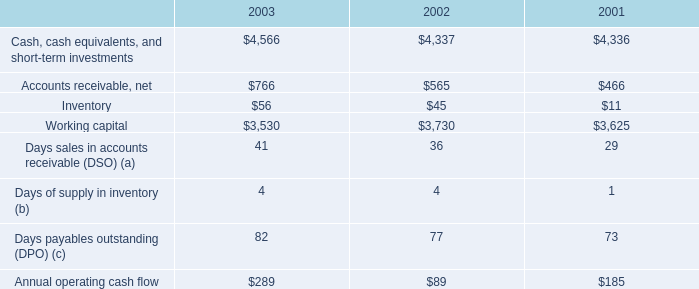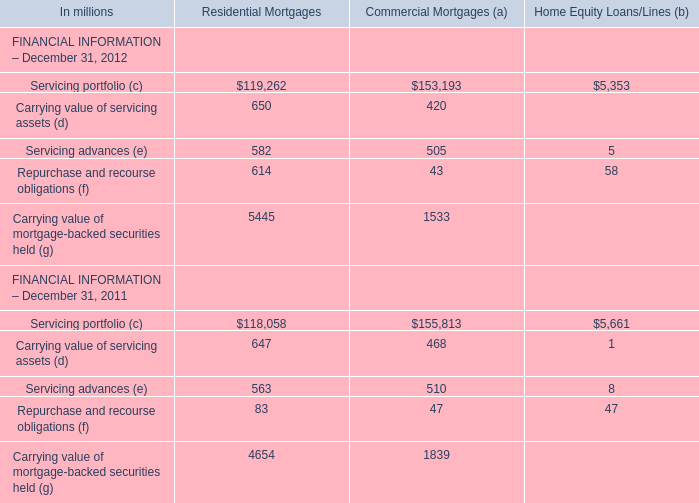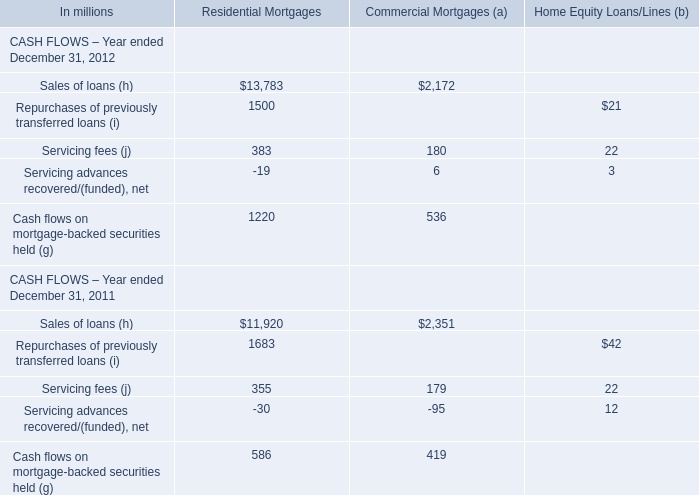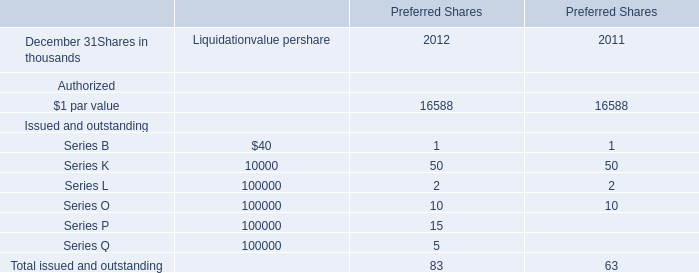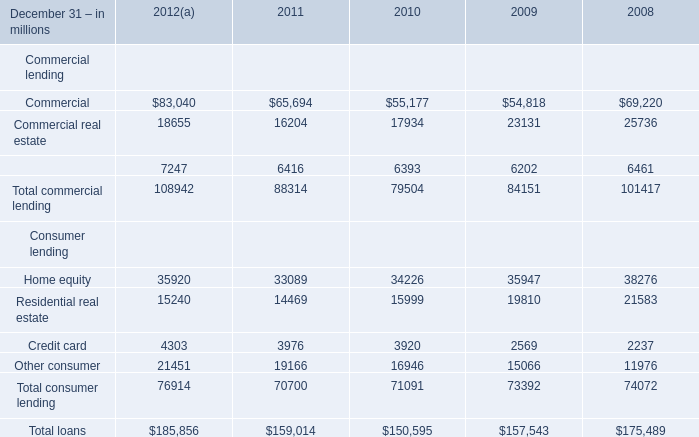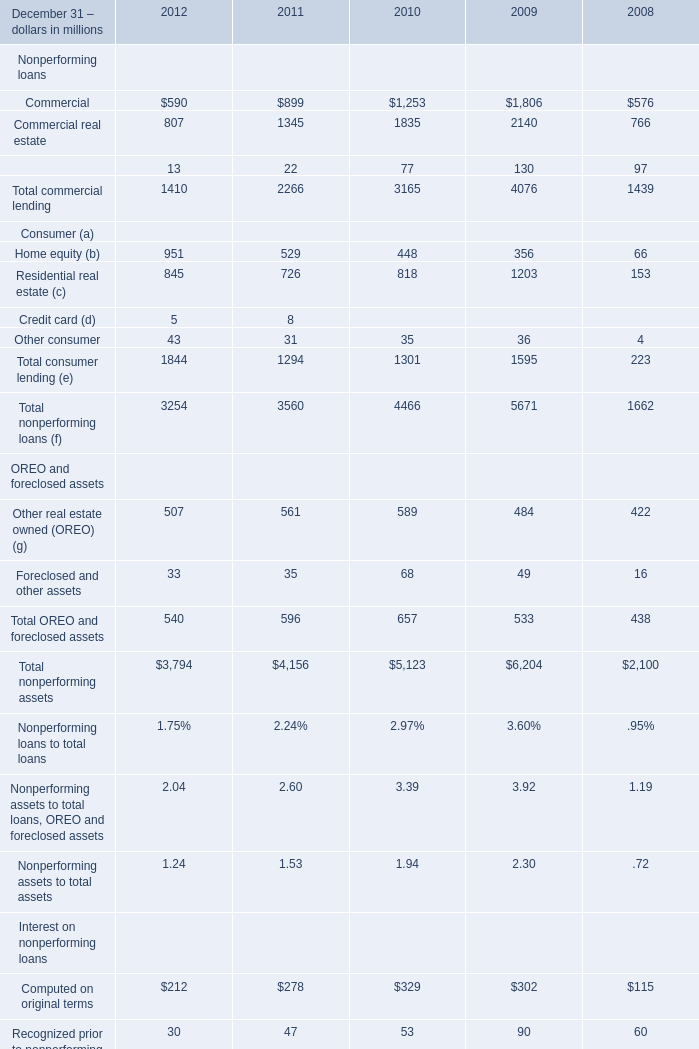Between 2010 and 2011,which year is the value of Total commercial lending on December 31 higher? 
Answer: 2011. 